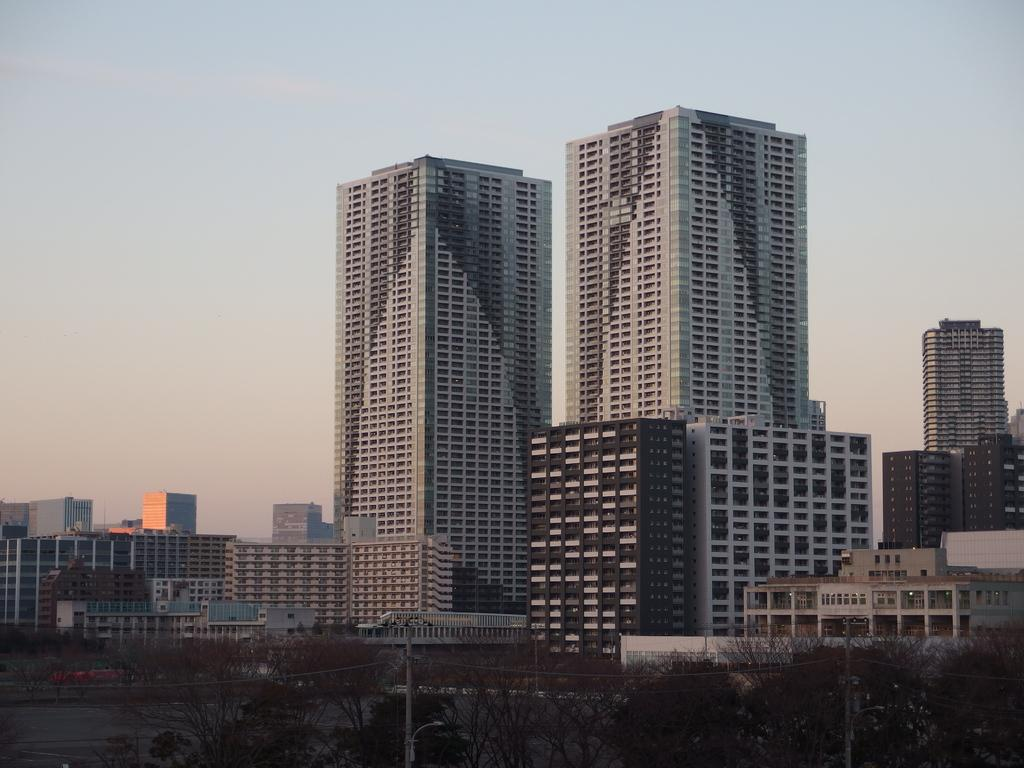What type of structures are present in the image? There are buildings in the image. What other natural elements can be seen in the image? There are trees and water on the ground in the image. What is the color of the sky in the background? The sky is blue in the background. Are there any weather conditions visible in the image? Yes, there are clouds in the sky in the background. How many women are shopping in the image? There are no women or shops present in the image. What type of trouble can be seen in the image? There is no trouble visible in the image; it appears to be a peaceful scene with buildings, trees, water, and a blue sky with clouds. 